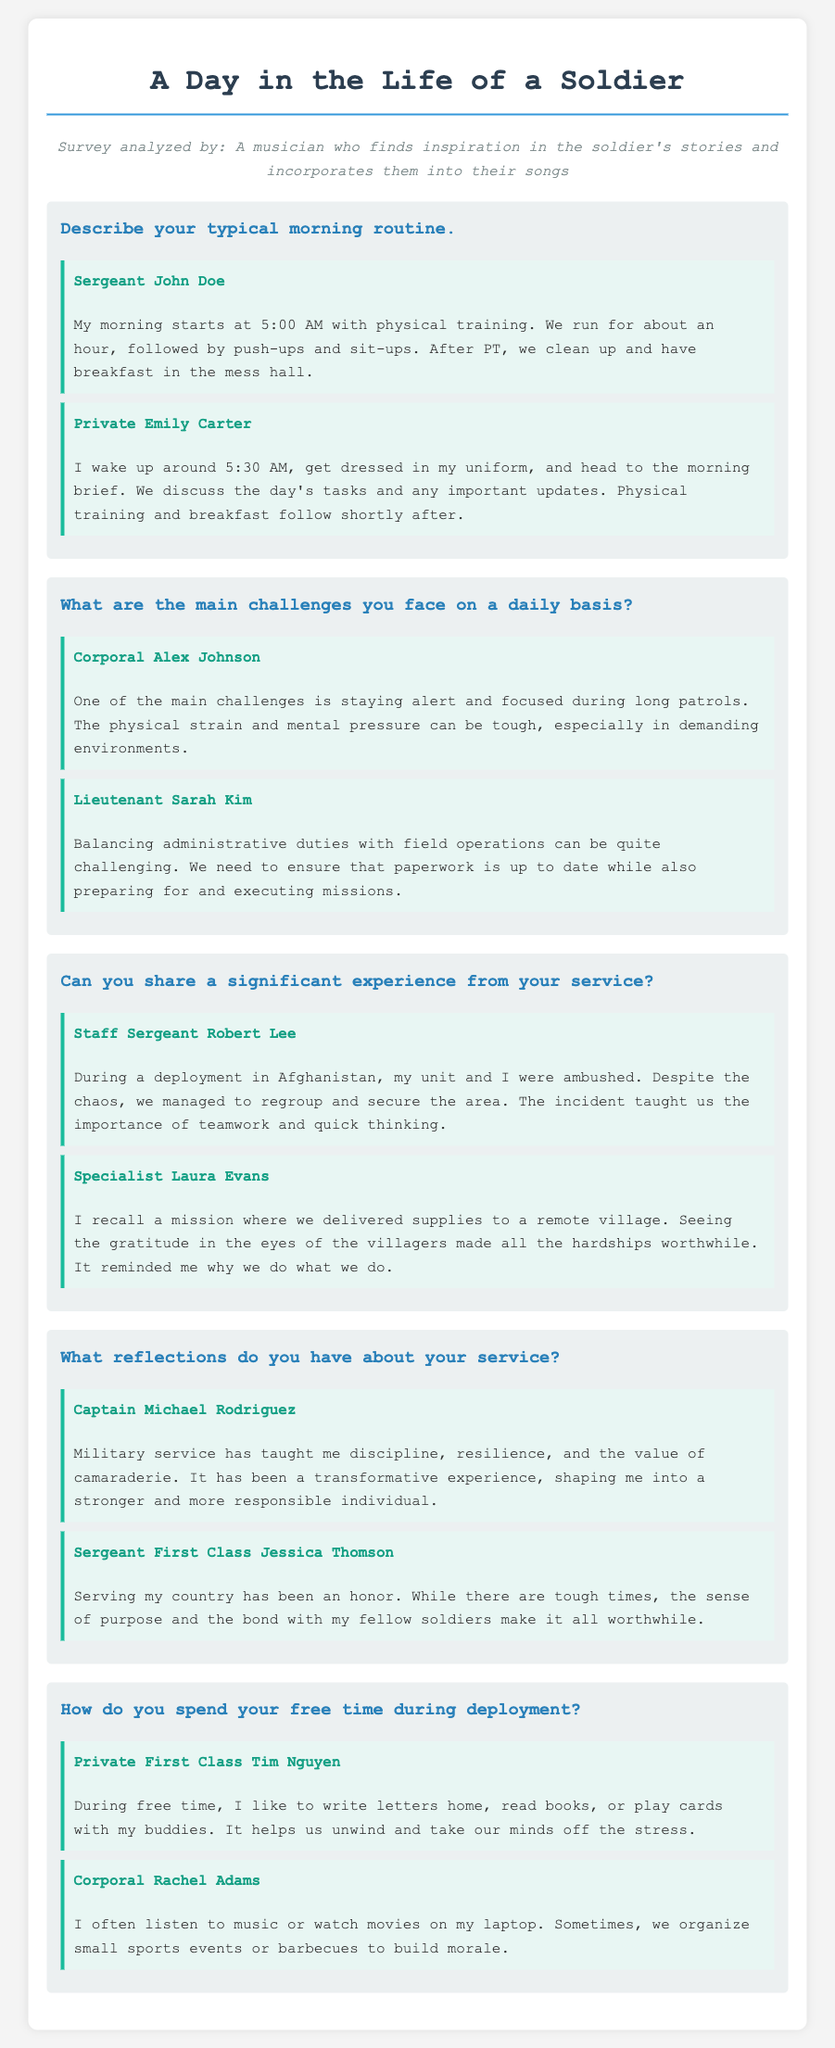What time does Sergeant John Doe wake up? The document states that Sergeant John Doe's morning starts at 5:00 AM.
Answer: 5:00 AM What is a primary challenge faced by Corporal Alex Johnson? Corporal Alex Johnson mentions staying alert and focused during long patrols as a main challenge.
Answer: Staying alert What significant experience did Staff Sergeant Robert Lee share? Staff Sergeant Robert Lee described an ambush during a deployment in Afghanistan and the importance of teamwork.
Answer: Ambushed in Afghanistan What does Captain Michael Rodriguez say military service has taught him? Captain Michael Rodriguez reflects that military service has taught him discipline, resilience, and camaraderie.
Answer: Discipline and resilience How does Private First Class Tim Nguyen spend his free time? Private First Class Tim Nguyen likes to write letters home, read books, or play cards during his free time.
Answer: Write letters, read books, play cards 